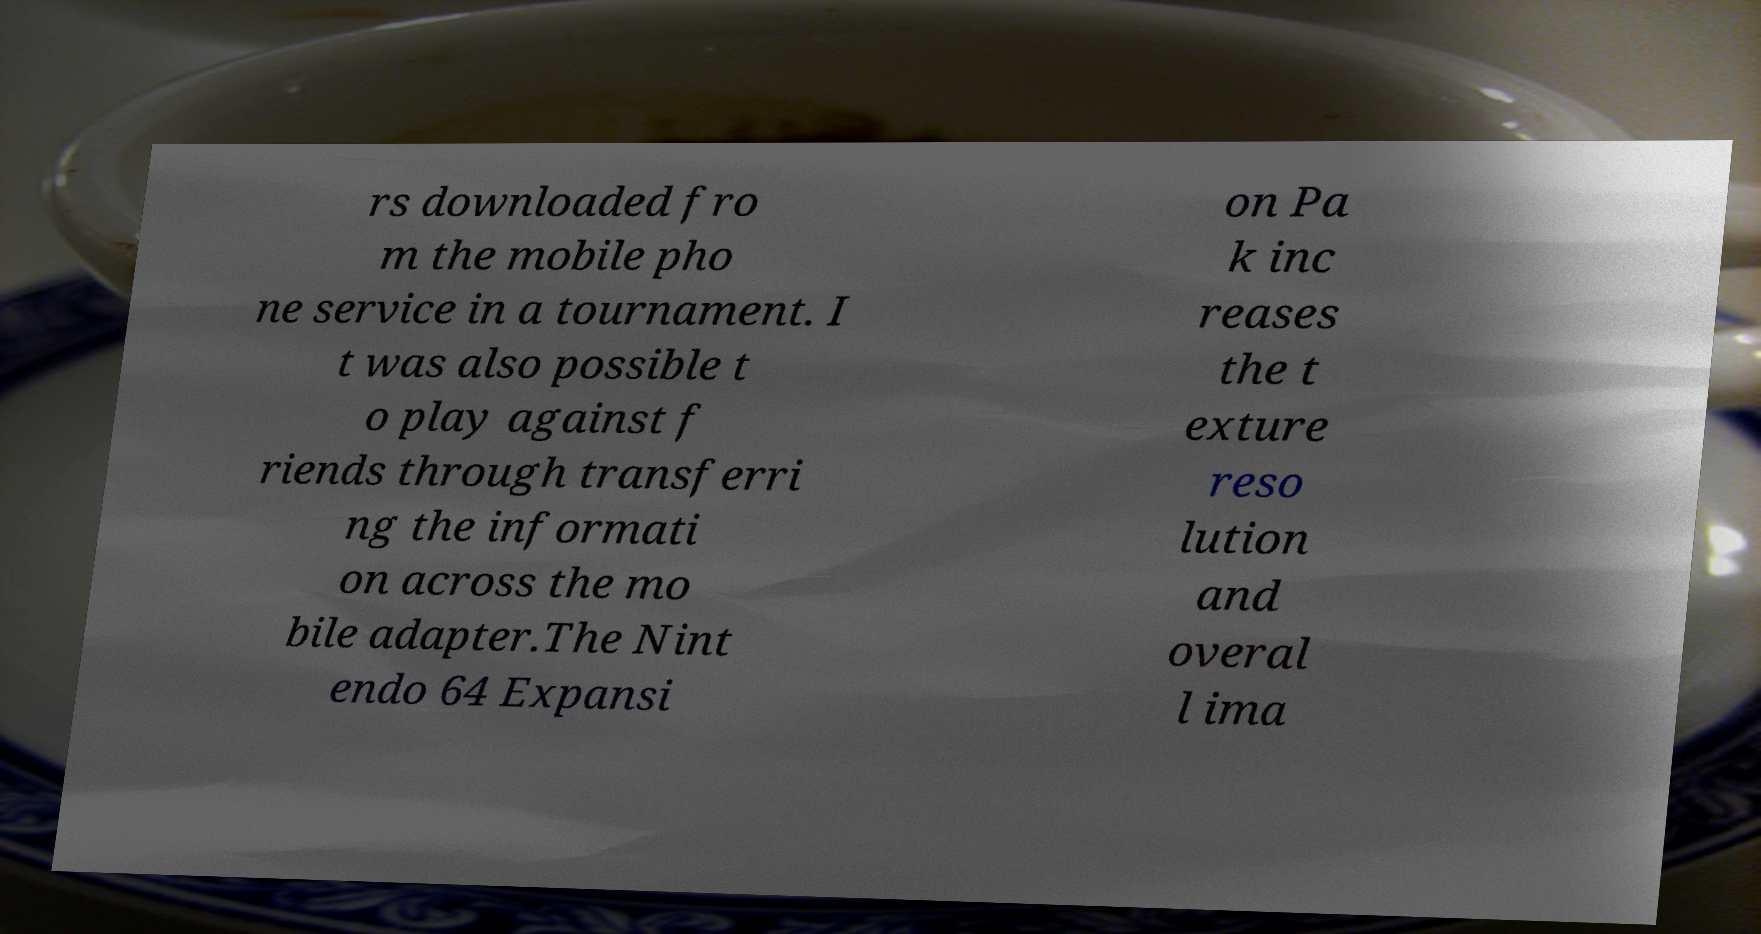Can you read and provide the text displayed in the image?This photo seems to have some interesting text. Can you extract and type it out for me? rs downloaded fro m the mobile pho ne service in a tournament. I t was also possible t o play against f riends through transferri ng the informati on across the mo bile adapter.The Nint endo 64 Expansi on Pa k inc reases the t exture reso lution and overal l ima 